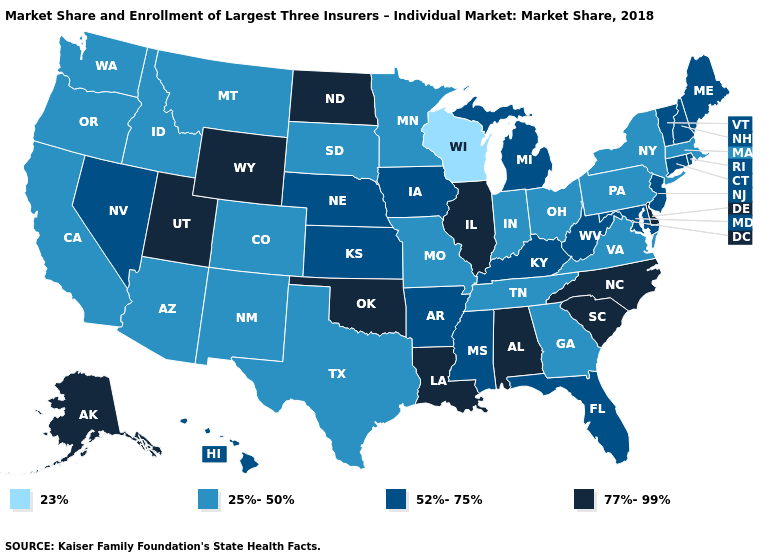What is the value of Oklahoma?
Quick response, please. 77%-99%. Name the states that have a value in the range 77%-99%?
Write a very short answer. Alabama, Alaska, Delaware, Illinois, Louisiana, North Carolina, North Dakota, Oklahoma, South Carolina, Utah, Wyoming. Among the states that border Iowa , which have the lowest value?
Keep it brief. Wisconsin. Does New Mexico have a lower value than Virginia?
Short answer required. No. What is the value of North Carolina?
Short answer required. 77%-99%. Name the states that have a value in the range 77%-99%?
Be succinct. Alabama, Alaska, Delaware, Illinois, Louisiana, North Carolina, North Dakota, Oklahoma, South Carolina, Utah, Wyoming. Name the states that have a value in the range 52%-75%?
Quick response, please. Arkansas, Connecticut, Florida, Hawaii, Iowa, Kansas, Kentucky, Maine, Maryland, Michigan, Mississippi, Nebraska, Nevada, New Hampshire, New Jersey, Rhode Island, Vermont, West Virginia. Does Connecticut have the lowest value in the Northeast?
Short answer required. No. What is the value of Ohio?
Concise answer only. 25%-50%. Does Oregon have the same value as Idaho?
Concise answer only. Yes. What is the value of West Virginia?
Be succinct. 52%-75%. What is the value of Illinois?
Write a very short answer. 77%-99%. Does New York have a lower value than Massachusetts?
Keep it brief. No. What is the lowest value in states that border Missouri?
Keep it brief. 25%-50%. Among the states that border South Dakota , does Nebraska have the lowest value?
Be succinct. No. 